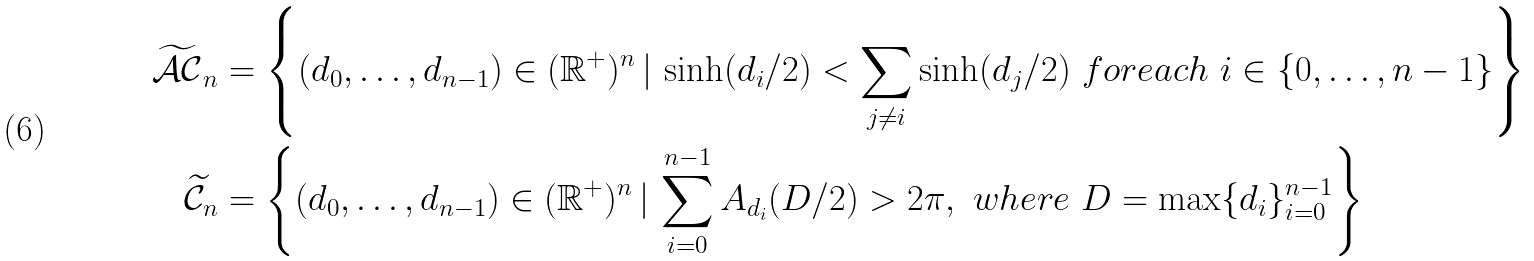<formula> <loc_0><loc_0><loc_500><loc_500>\widetilde { \mathcal { A C } } _ { n } & = \left \{ ( d _ { 0 } , \hdots , d _ { n - 1 } ) \in ( \mathbb { R } ^ { + } ) ^ { n } \, | \, \sinh ( d _ { i } / 2 ) < \sum _ { j \neq i } \sinh ( d _ { j } / 2 ) \ f o r e a c h \ i \in \{ 0 , \hdots , n - 1 \} \right \} \\ \widetilde { \mathcal { C } } _ { n } & = \left \{ ( d _ { 0 } , \hdots , d _ { n - 1 } ) \in ( \mathbb { R } ^ { + } ) ^ { n } \, | \, \sum _ { i = 0 } ^ { n - 1 } A _ { d _ { i } } ( D / 2 ) > 2 \pi , \ w h e r e \ D = \max \{ d _ { i } \} _ { i = 0 } ^ { n - 1 } \right \}</formula> 